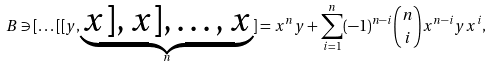Convert formula to latex. <formula><loc_0><loc_0><loc_500><loc_500>B \ni [ \dots [ [ y , \underbrace { x ] , x ] , \dots , x } _ { n } ] = x ^ { n } y + \sum _ { i = 1 } ^ { n } ( - 1 ) ^ { n - i } \binom { n } { i } x ^ { n - i } y x ^ { i } ,</formula> 